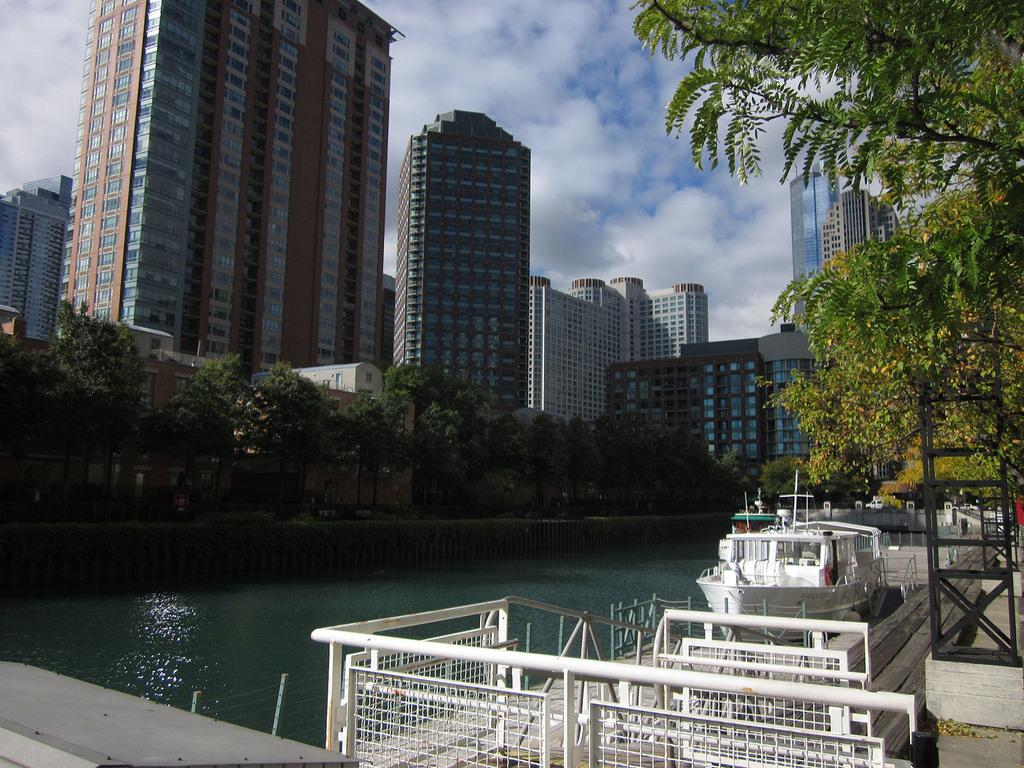What type of structures can be seen in the image? There are buildings in the image. What is located on the water in the image? There is a ship on the water in the image. What type of vegetation is present in the image? There are trees in the image. What type of architectural feature can be seen in the image? Iron grills are present in the image. What is visible in the background of the image? The sky is visible in the image, and clouds are present in the sky. How is the ship being washed in the image? There is no indication in the image that the ship is being washed; it is simply located on the water. What type of hose is connected to the trees in the image? There is no hose present in the image; it only features trees, buildings, a ship, iron grills, and the sky. 